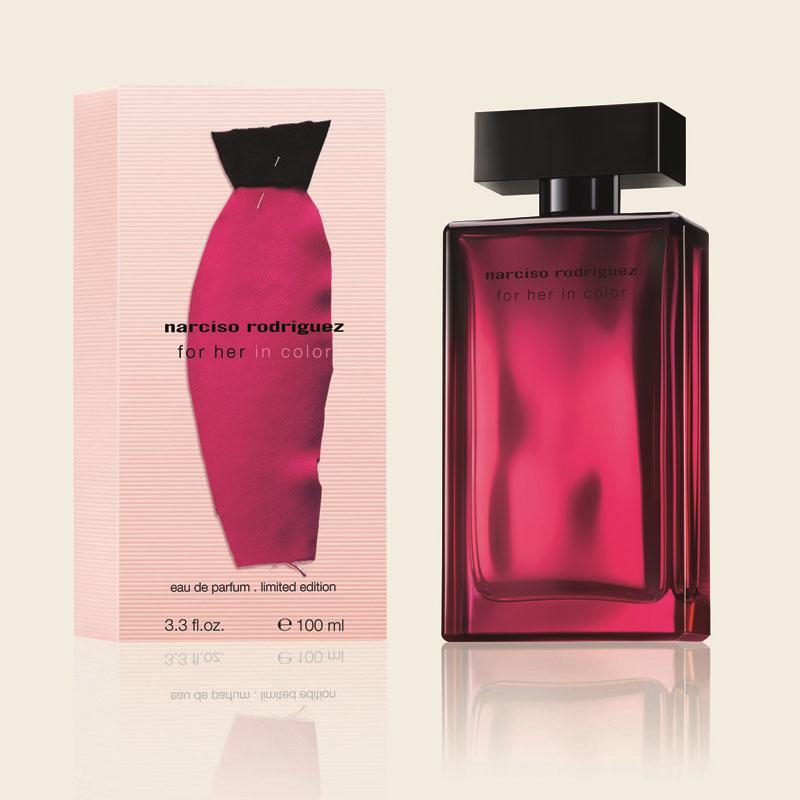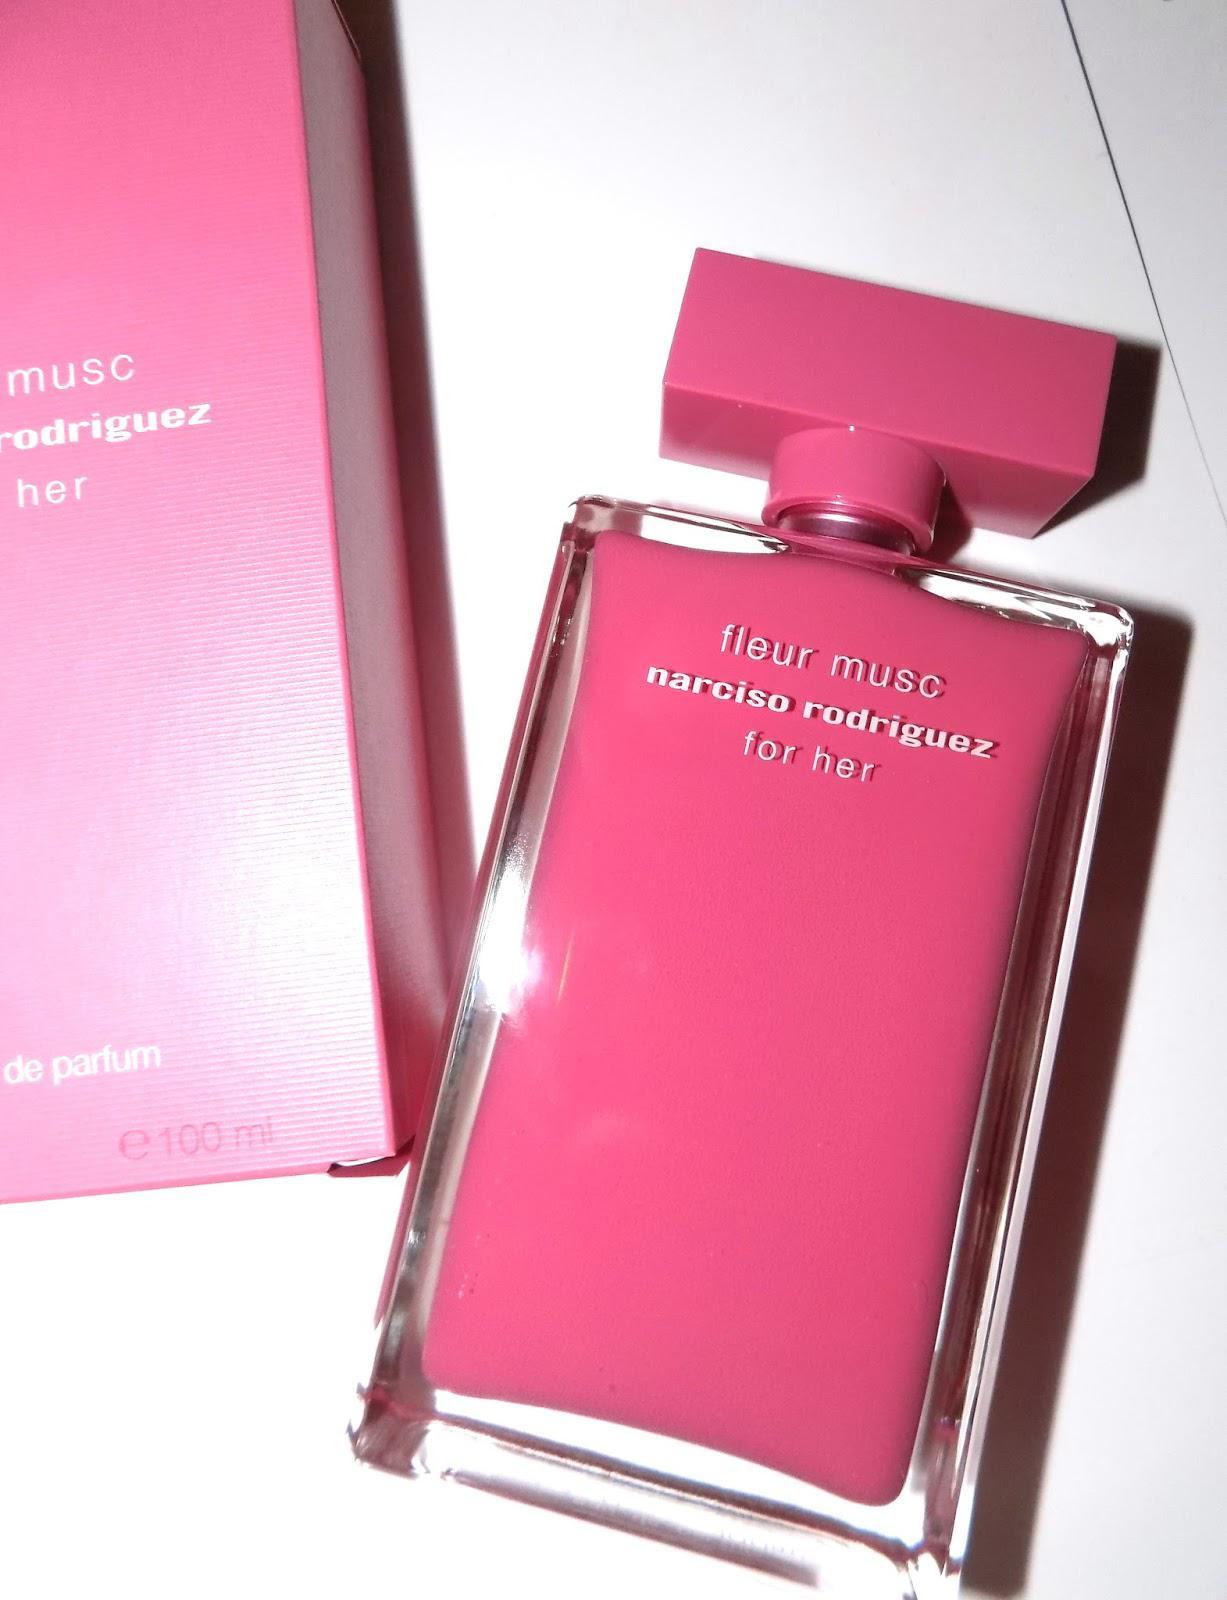The first image is the image on the left, the second image is the image on the right. Considering the images on both sides, is "No single image contains more than one fragrance bottle, and the bottles on the left and right are at least very similar in size, shape, and color." valid? Answer yes or no. Yes. The first image is the image on the left, the second image is the image on the right. Assess this claim about the two images: "There is a visible reflection off the table in one of the images.". Correct or not? Answer yes or no. Yes. 